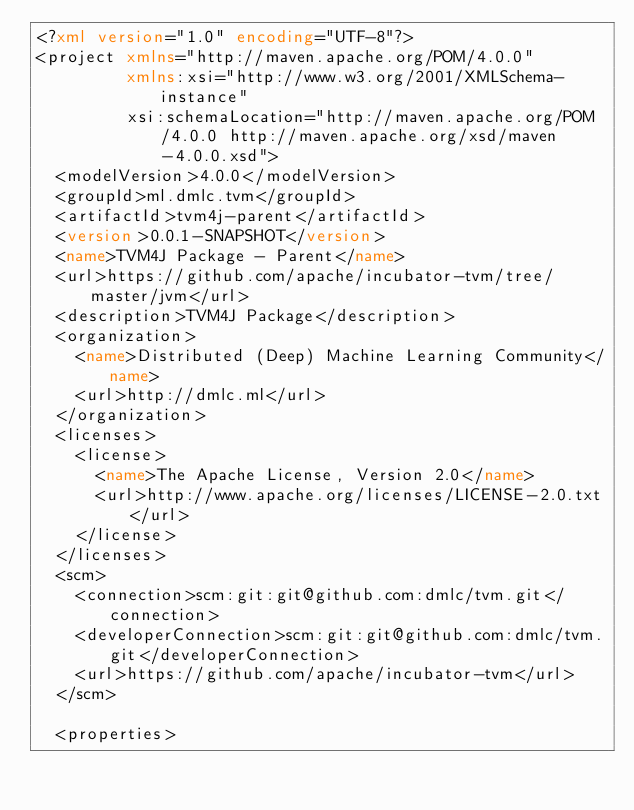Convert code to text. <code><loc_0><loc_0><loc_500><loc_500><_XML_><?xml version="1.0" encoding="UTF-8"?>
<project xmlns="http://maven.apache.org/POM/4.0.0"
         xmlns:xsi="http://www.w3.org/2001/XMLSchema-instance"
         xsi:schemaLocation="http://maven.apache.org/POM/4.0.0 http://maven.apache.org/xsd/maven-4.0.0.xsd">
  <modelVersion>4.0.0</modelVersion>
  <groupId>ml.dmlc.tvm</groupId>
  <artifactId>tvm4j-parent</artifactId>
  <version>0.0.1-SNAPSHOT</version>
  <name>TVM4J Package - Parent</name>
  <url>https://github.com/apache/incubator-tvm/tree/master/jvm</url>
  <description>TVM4J Package</description>
  <organization>
    <name>Distributed (Deep) Machine Learning Community</name>
    <url>http://dmlc.ml</url>
  </organization>
  <licenses>
    <license>
      <name>The Apache License, Version 2.0</name>
      <url>http://www.apache.org/licenses/LICENSE-2.0.txt</url>
    </license>
  </licenses>
  <scm>
    <connection>scm:git:git@github.com:dmlc/tvm.git</connection>
    <developerConnection>scm:git:git@github.com:dmlc/tvm.git</developerConnection>
    <url>https://github.com/apache/incubator-tvm</url>
  </scm>

  <properties></code> 